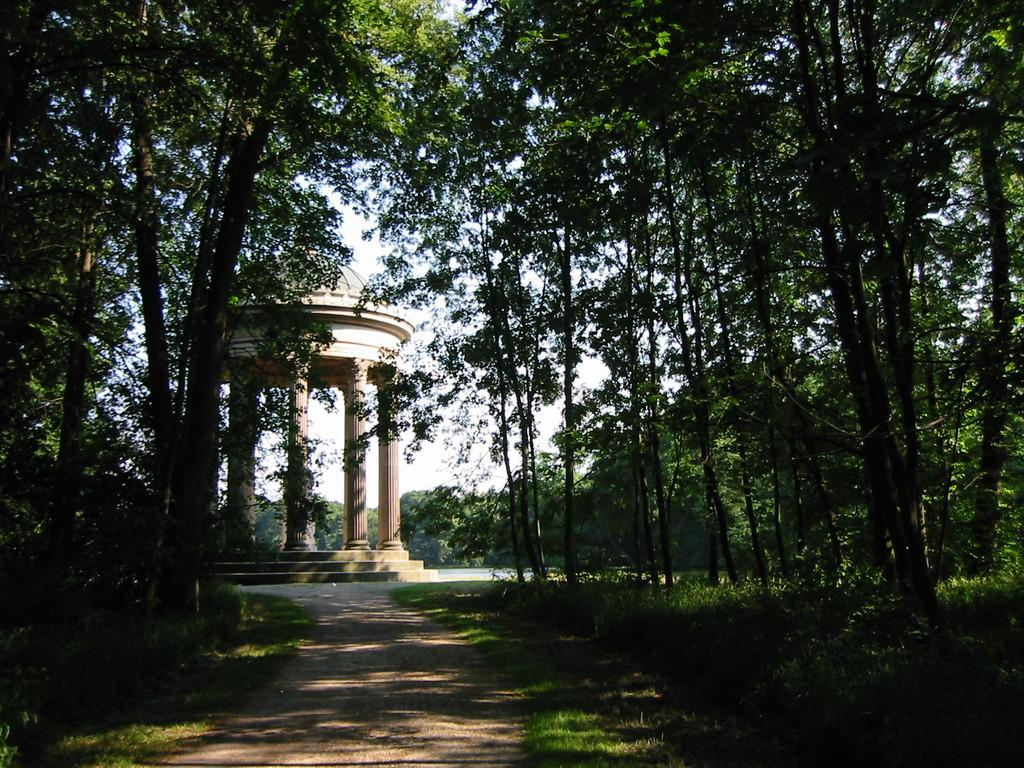What is the main feature of the image? There is a road in the image. What can be seen on either side of the road? Trees are present on either side of the road. What structure is visible in the image? There is a gazebo in the image. What is visible in the background of the image? The sky is visible in the background of the image. What type of plate is being used to serve food in the image? There is no plate or food present in the image; it features a road, trees, a gazebo, and the sky. 